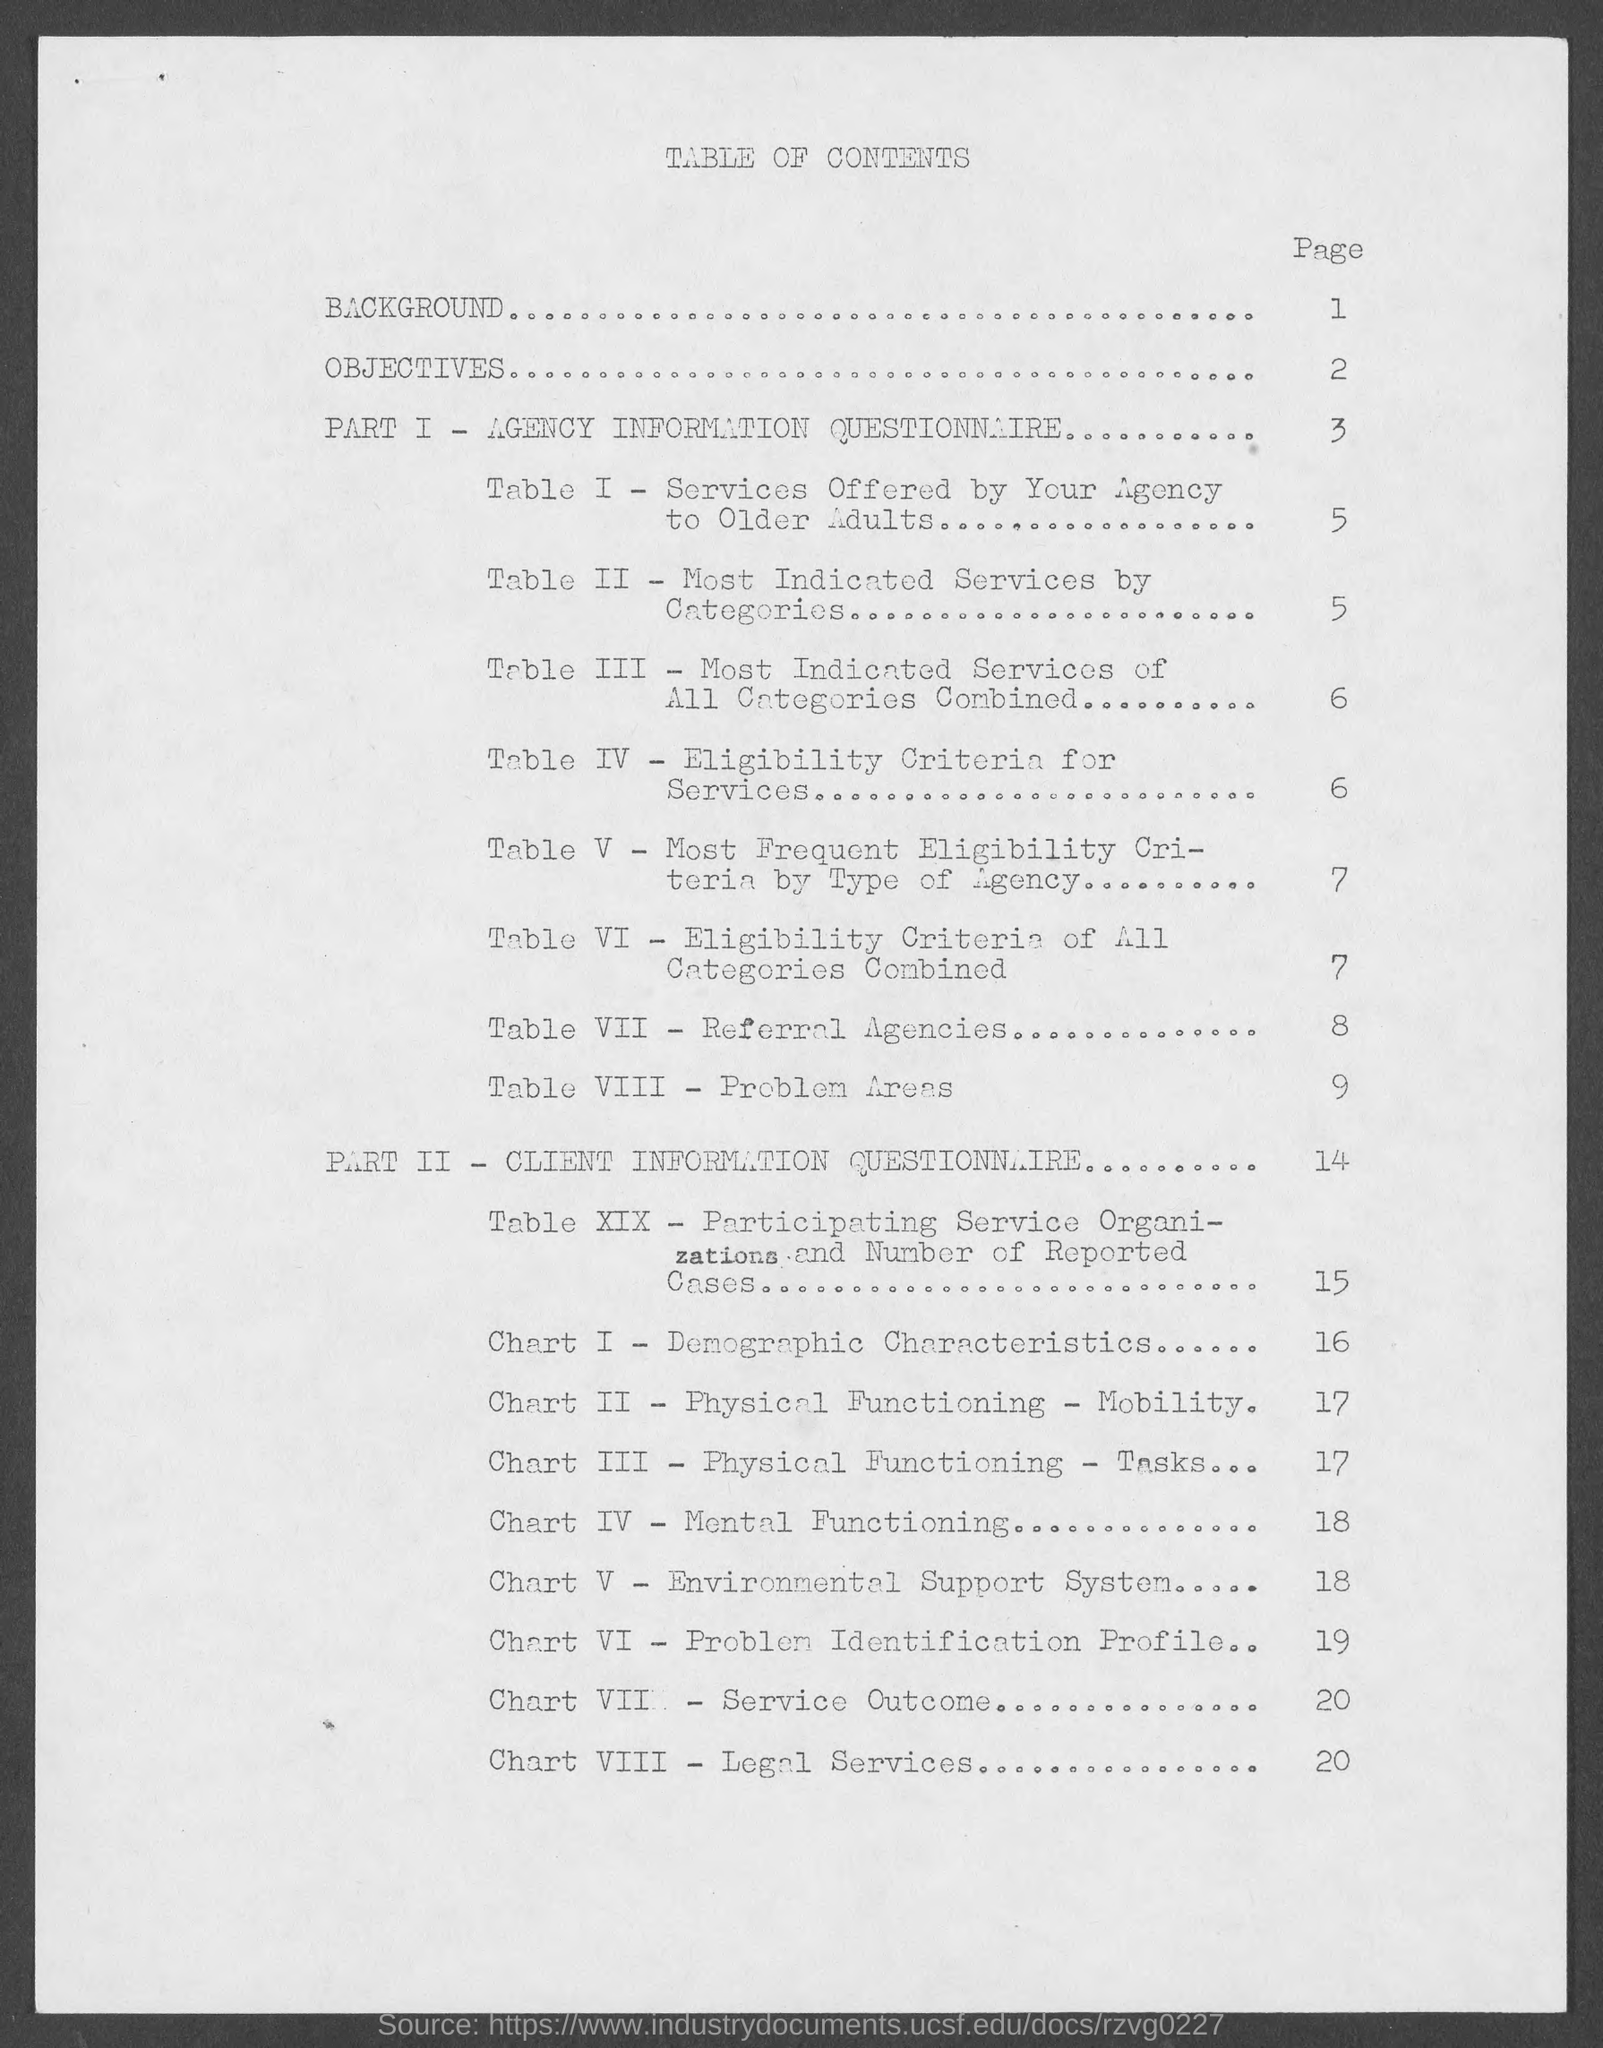Specify some key components in this picture. The Part-1 in this document is AGENCY INFORMATION QUESTIONNAIRE. This document is the Part-2 of a CLIENT INFORMATION QUESTIONNAIRE. The page number of "Eligibility Criteria for Services" is 6. 